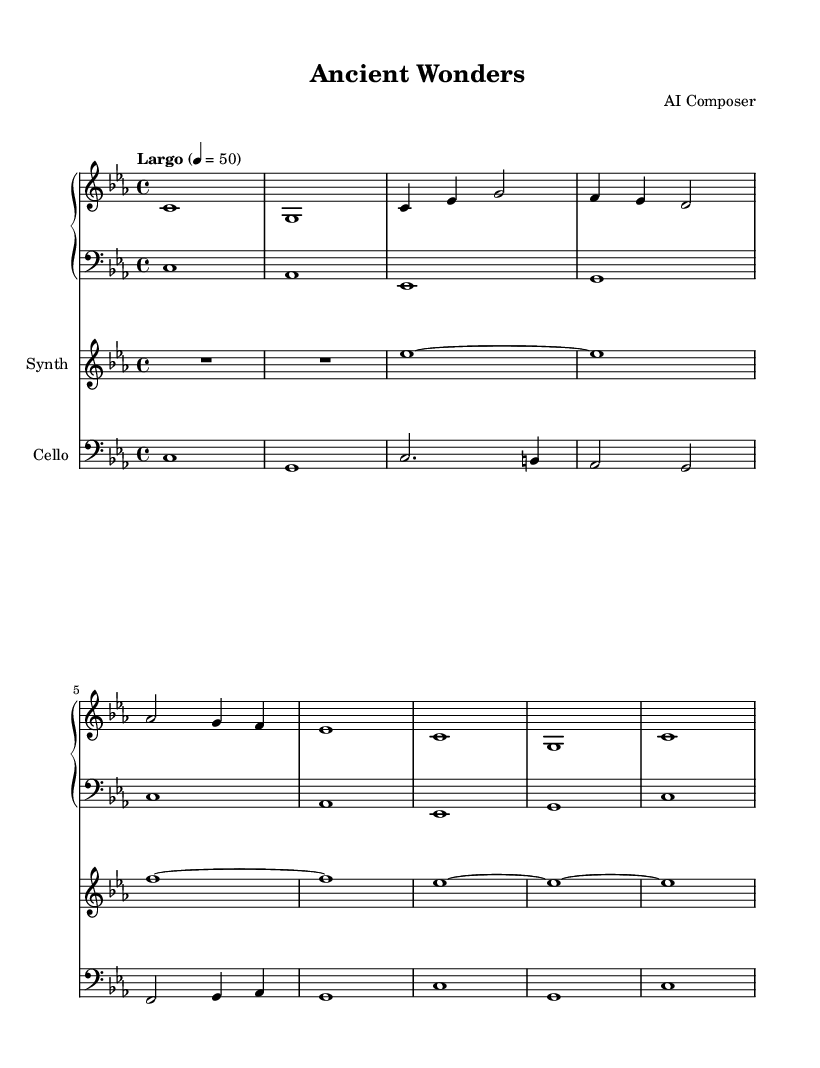What is the key signature of this music? The key signature indicates C minor, which has three flats (B♭, E♭, and A♭). This can be seen at the beginning of the score, represented by the flat symbols in the key signature.
Answer: C minor What is the time signature of this piece? The time signature is found at the beginning of the score and is represented as 4/4. This means there are four beats in each measure and the quarter note gets one beat.
Answer: 4/4 What is the tempo marking of the music? The tempo marking is labeled as Largo, with a metronome marking of quarter note equals 50. This indicates a slow tempo, specifically how fast the piece should be played.
Answer: Largo How many measures are present in the piano part? The measures in the piano part can be counted from the start to the end of the written music. By visually inspecting, we can identify a total of 8 distinct measures.
Answer: 8 Which instrument plays the lowest part in the score? By observing the layout of the instruments, the cello part is in the bass clef, which typically indicates lower pitches than the other parts (piano and synth). Thus, the cello plays the lowest.
Answer: Cello What is the final note of the synth part? The synth part ends with an es note, which can be identified from the last measure of the score, indicating the last played note for that instrument.
Answer: es 